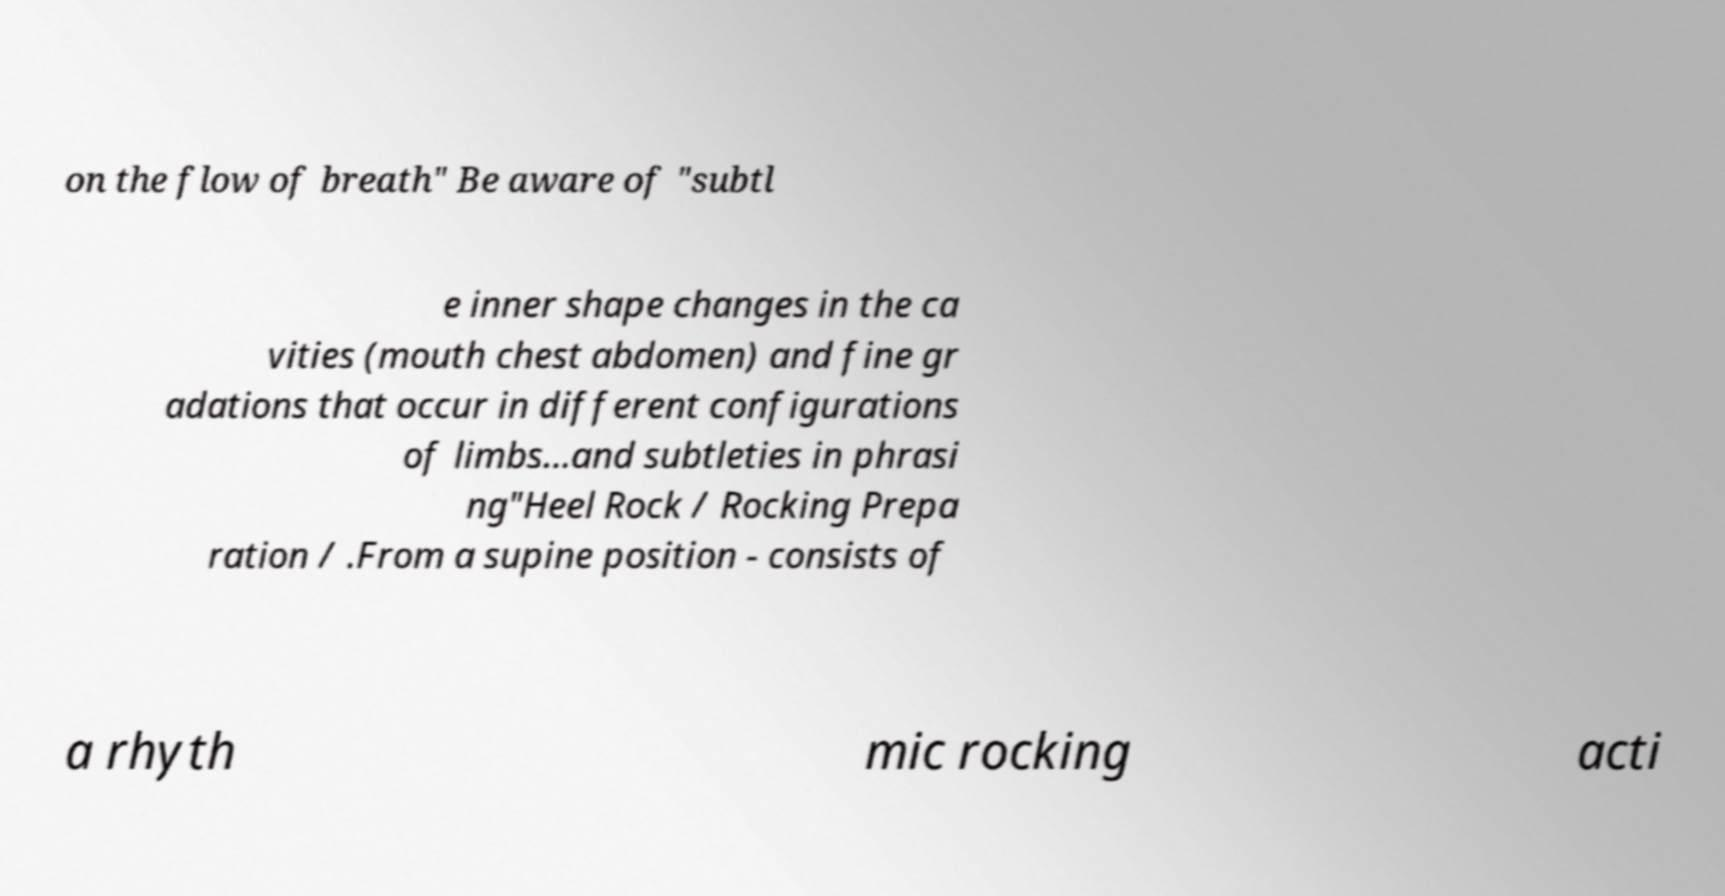There's text embedded in this image that I need extracted. Can you transcribe it verbatim? on the flow of breath" Be aware of "subtl e inner shape changes in the ca vities (mouth chest abdomen) and fine gr adations that occur in different configurations of limbs...and subtleties in phrasi ng"Heel Rock / Rocking Prepa ration / .From a supine position - consists of a rhyth mic rocking acti 